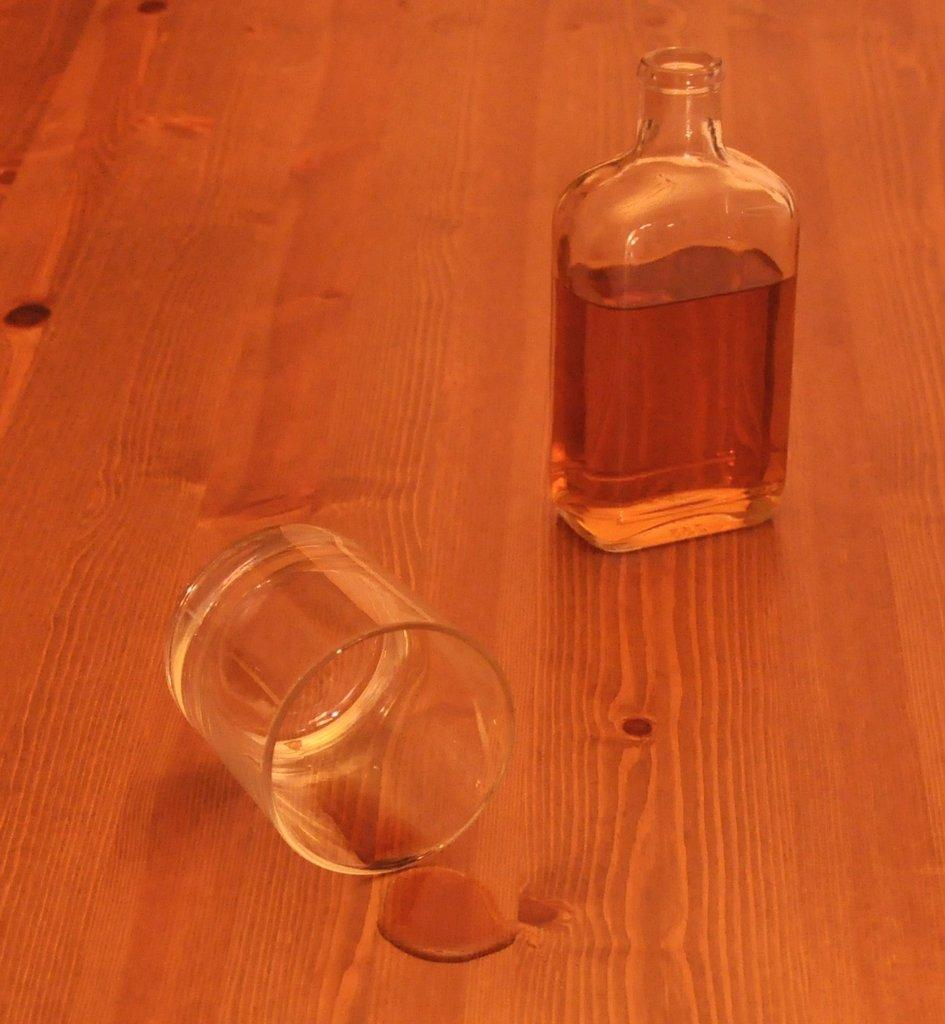What is present in the image that can hold a drink? There is a glass and a bottle in the image. What do the glass and bottle contain? The glass and bottle contain a drink. Reasoning: Let's think step by step by step in order to produce the conversation. We start by identifying the main subjects in the image, which are the glass and bottle. Then, we focus on their purpose, which is to hold a drink. Each question is designed to elicit a specific detail about the image that is known from the provided facts. Absurd Question/Answer: What type of coast can be seen in the image? There is no coast present in the image; it only features a glass and a bottle containing a drink. Can you see someone smiling in the image? There is no person present in the image, so it is not possible to see someone smiling. 